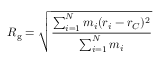<formula> <loc_0><loc_0><loc_500><loc_500>R _ { g } = { \sqrt { \frac { \sum _ { i = 1 } ^ { N } m _ { i } ( r _ { i } - r _ { C } ) ^ { 2 } } { \sum _ { i = 1 } ^ { N } m _ { i } } } }</formula> 